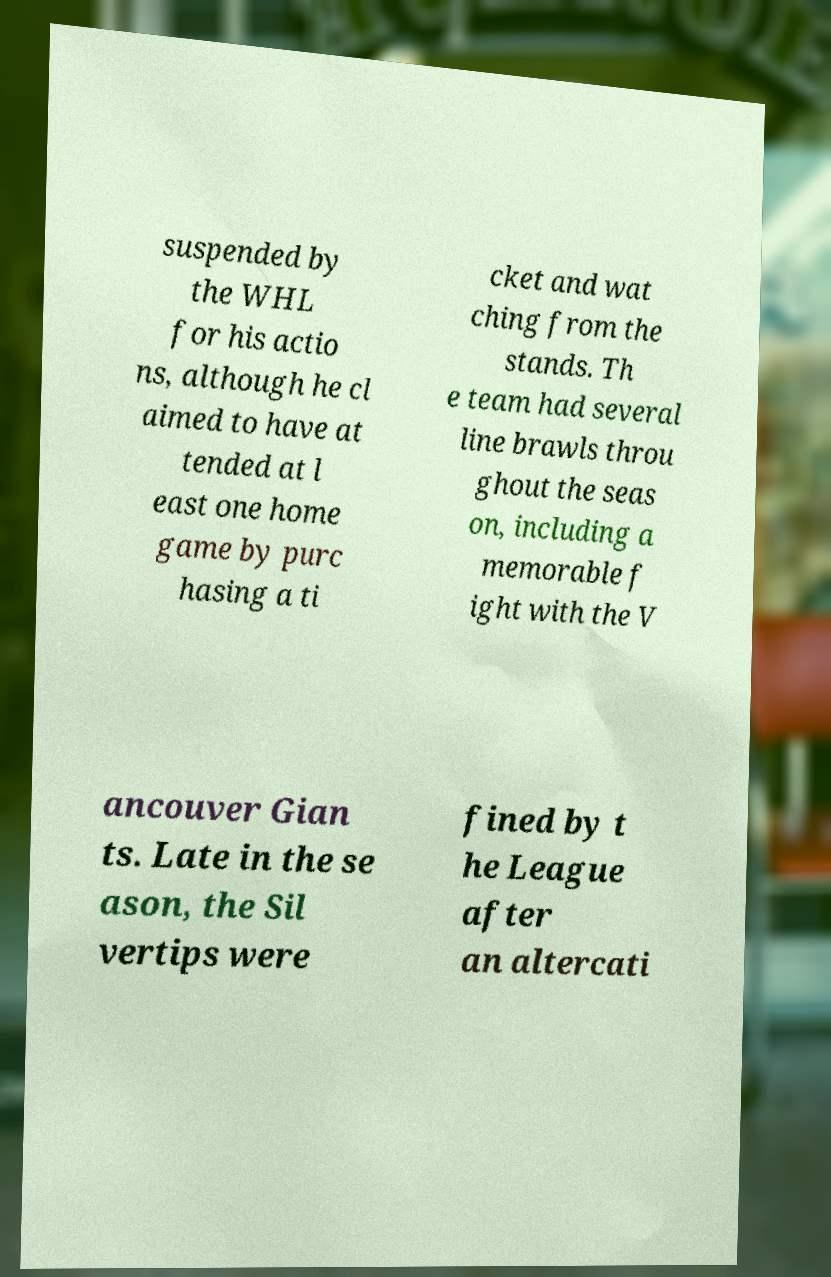Could you extract and type out the text from this image? suspended by the WHL for his actio ns, although he cl aimed to have at tended at l east one home game by purc hasing a ti cket and wat ching from the stands. Th e team had several line brawls throu ghout the seas on, including a memorable f ight with the V ancouver Gian ts. Late in the se ason, the Sil vertips were fined by t he League after an altercati 